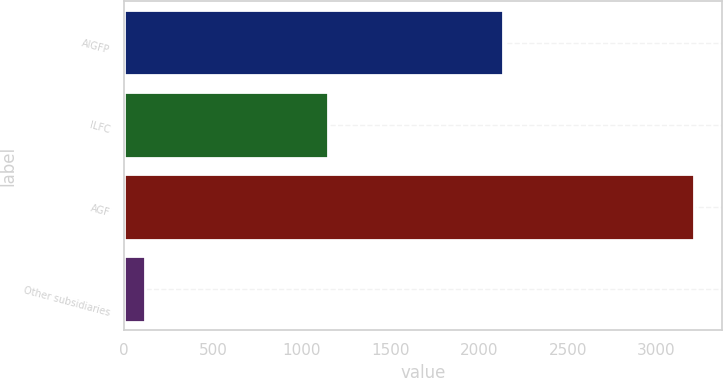<chart> <loc_0><loc_0><loc_500><loc_500><bar_chart><fcel>AIGFP<fcel>ILFC<fcel>AGF<fcel>Other subsidiaries<nl><fcel>2132<fcel>1151<fcel>3209<fcel>114<nl></chart> 